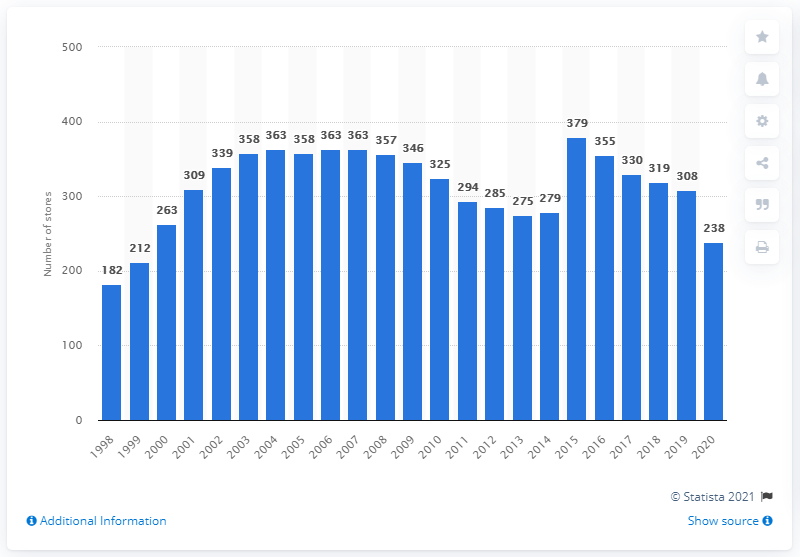Give some essential details in this illustration. In the prior year, Abercrombie & Fitch had a total of 308 stores. Abercrombie & Fitch operated 238 stores in 2020. 